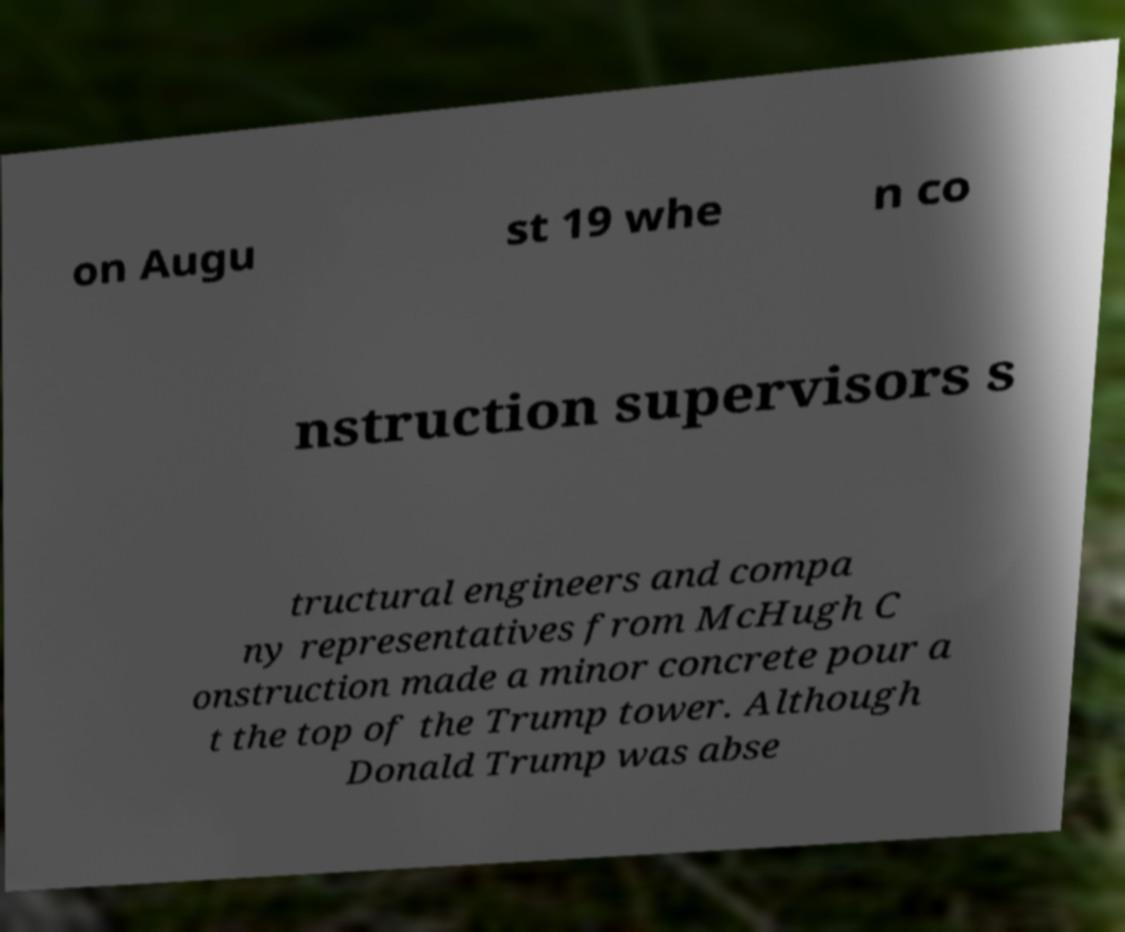Please read and relay the text visible in this image. What does it say? on Augu st 19 whe n co nstruction supervisors s tructural engineers and compa ny representatives from McHugh C onstruction made a minor concrete pour a t the top of the Trump tower. Although Donald Trump was abse 